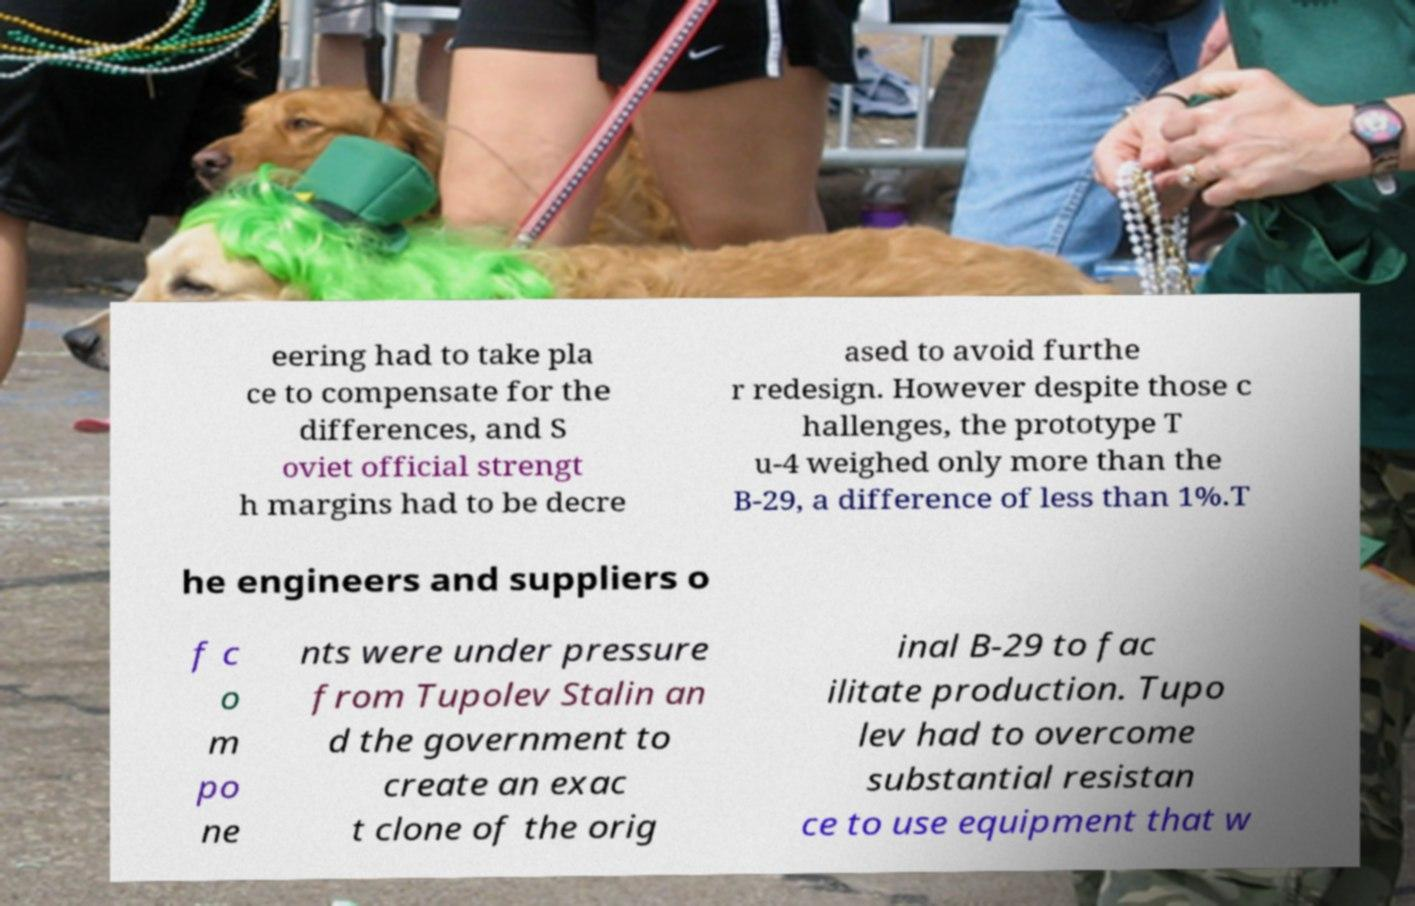Could you extract and type out the text from this image? eering had to take pla ce to compensate for the differences, and S oviet official strengt h margins had to be decre ased to avoid furthe r redesign. However despite those c hallenges, the prototype T u-4 weighed only more than the B-29, a difference of less than 1%.T he engineers and suppliers o f c o m po ne nts were under pressure from Tupolev Stalin an d the government to create an exac t clone of the orig inal B-29 to fac ilitate production. Tupo lev had to overcome substantial resistan ce to use equipment that w 